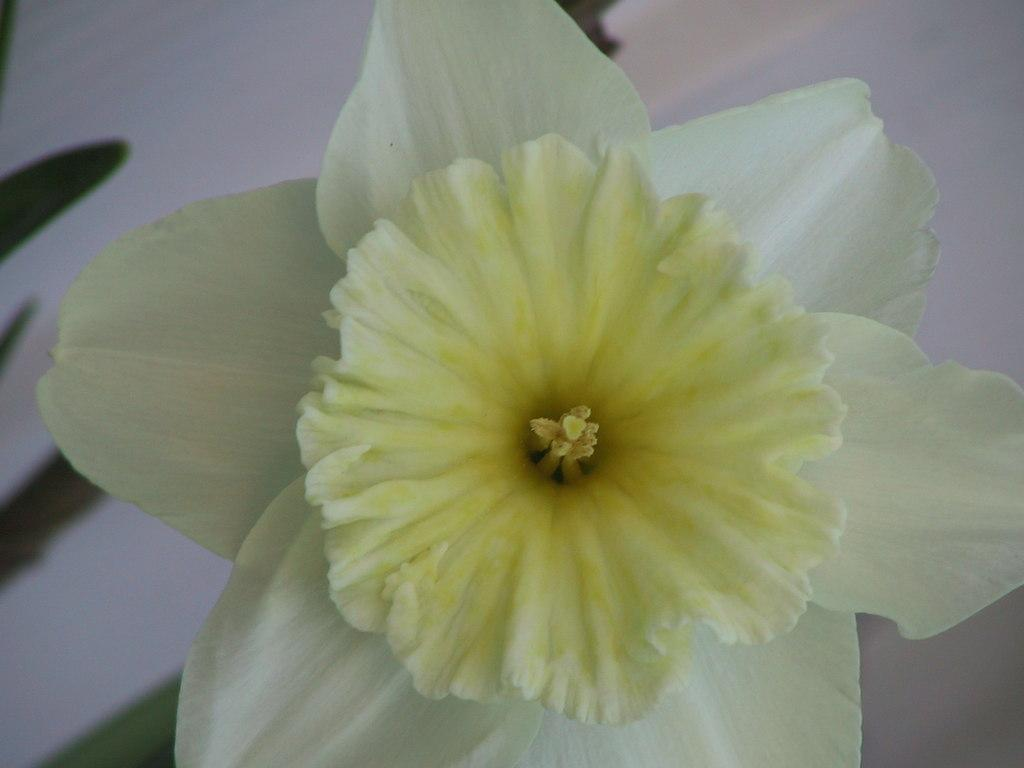What is the main subject of the image? There is a flower in the image. What color is the background of the image? The background of the image is white. How many sisters are present in the image? There are no sisters present in the image; it features a flower against a white background. What type of sweater is the flower wearing in the image? The flower is not wearing a sweater, as it is a plant and not a person. 